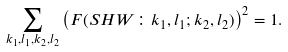<formula> <loc_0><loc_0><loc_500><loc_500>\sum _ { k _ { 1 } , l _ { 1 } , k _ { 2 } , l _ { 2 } } \left ( F ( S H W \colon k _ { 1 } , l _ { 1 } ; k _ { 2 } , l _ { 2 } ) \right ) ^ { 2 } = 1 .</formula> 